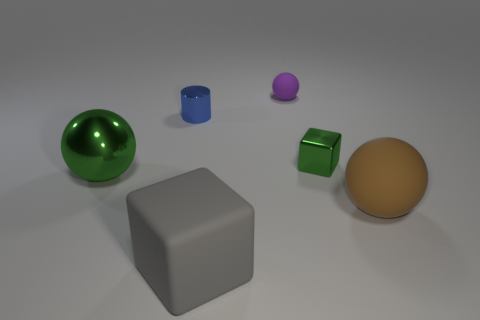How many objects are objects that are to the left of the gray matte block or matte things behind the tiny green shiny cube?
Your answer should be compact. 3. The big object left of the cube in front of the green metal ball is what shape?
Your answer should be very brief. Sphere. Are there any other things that have the same color as the metal cylinder?
Your response must be concise. No. Are there any other things that have the same size as the purple matte sphere?
Your response must be concise. Yes. What number of objects are large green blocks or big matte things?
Keep it short and to the point. 2. Are there any blue things that have the same size as the purple sphere?
Your answer should be compact. Yes. What is the shape of the blue metal thing?
Make the answer very short. Cylinder. Are there more big metallic balls that are left of the green metal sphere than brown things that are left of the purple rubber object?
Offer a terse response. No. There is a tiny metallic thing that is on the left side of the big gray rubber cube; does it have the same color as the matte block that is in front of the green metal sphere?
Ensure brevity in your answer.  No. What is the shape of the rubber object that is the same size as the green metallic cube?
Ensure brevity in your answer.  Sphere. 